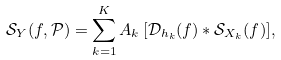<formula> <loc_0><loc_0><loc_500><loc_500>\mathcal { S } _ { Y } ( f , \mathcal { P } ) = \sum _ { k = 1 } ^ { K } A _ { k } \, [ \mathcal { D } _ { h _ { k } } ( f ) * \mathcal { S } _ { X _ { k } } ( f ) ] ,</formula> 